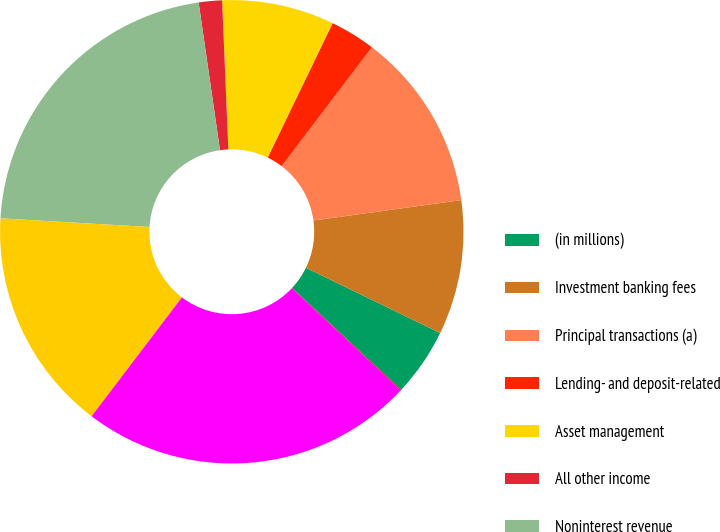Convert chart. <chart><loc_0><loc_0><loc_500><loc_500><pie_chart><fcel>(in millions)<fcel>Investment banking fees<fcel>Principal transactions (a)<fcel>Lending- and deposit-related<fcel>Asset management<fcel>All other income<fcel>Noninterest revenue<fcel>Net interest income<fcel>Total net revenue (b)<fcel>Provision for credit losses<nl><fcel>4.73%<fcel>9.38%<fcel>12.48%<fcel>3.17%<fcel>7.83%<fcel>1.62%<fcel>21.79%<fcel>15.58%<fcel>23.34%<fcel>0.07%<nl></chart> 